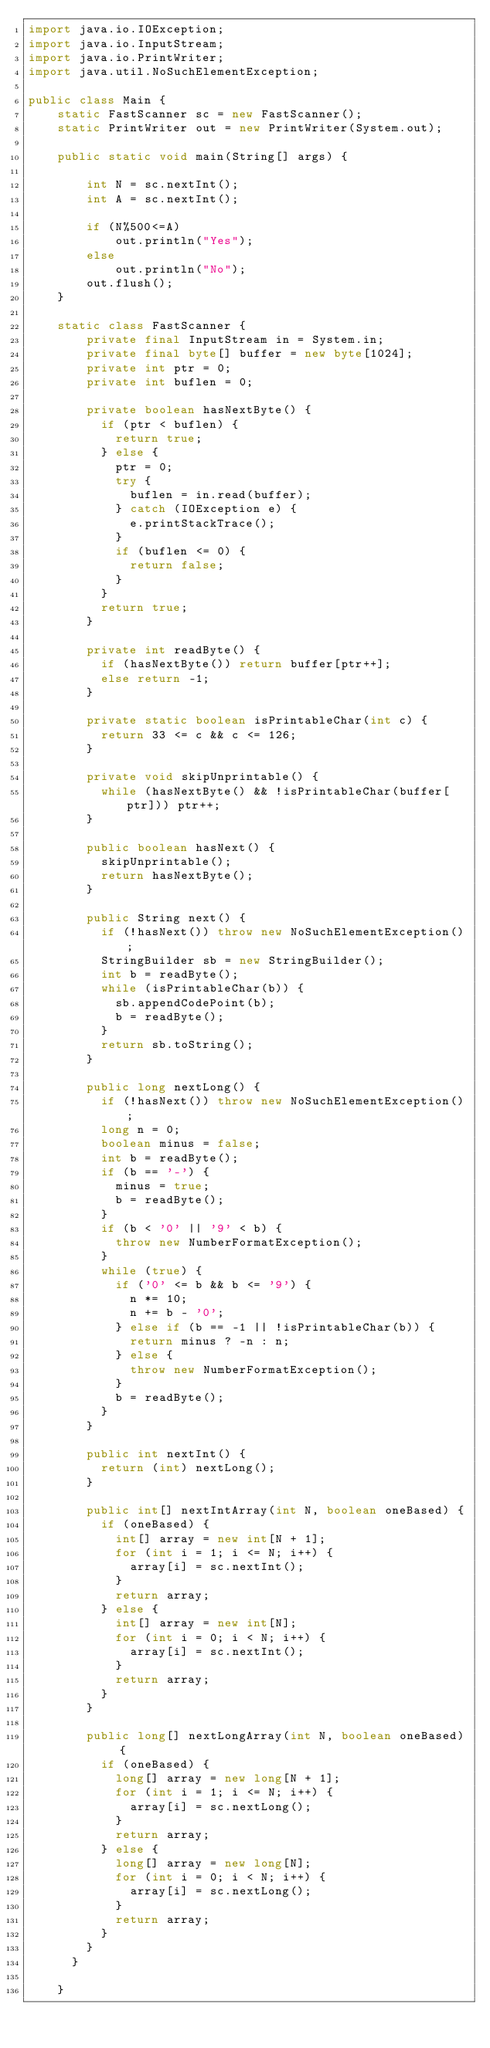<code> <loc_0><loc_0><loc_500><loc_500><_Java_>import java.io.IOException;
import java.io.InputStream;
import java.io.PrintWriter;
import java.util.NoSuchElementException;

public class Main {
	static FastScanner sc = new FastScanner();
	static PrintWriter out = new PrintWriter(System.out);
	
	public static void main(String[] args) {
		
		int N = sc.nextInt();
		int A = sc.nextInt();
		
		if (N%500<=A)
			out.println("Yes");
		else
			out.println("No");
		out.flush();
	}
	
	static class FastScanner {
	    private final InputStream in = System.in;
	    private final byte[] buffer = new byte[1024];
	    private int ptr = 0;
	    private int buflen = 0;

	    private boolean hasNextByte() {
	      if (ptr < buflen) {
	        return true;
	      } else {
	        ptr = 0;
	        try {
	          buflen = in.read(buffer);
	        } catch (IOException e) {
	          e.printStackTrace();
	        }
	        if (buflen <= 0) {
	          return false;
	        }
	      }
	      return true;
	    }

	    private int readByte() {
	      if (hasNextByte()) return buffer[ptr++];
	      else return -1;
	    }

	    private static boolean isPrintableChar(int c) {
	      return 33 <= c && c <= 126;
	    }

	    private void skipUnprintable() {
	      while (hasNextByte() && !isPrintableChar(buffer[ptr])) ptr++;
	    }

	    public boolean hasNext() {
	      skipUnprintable();
	      return hasNextByte();
	    }

	    public String next() {
	      if (!hasNext()) throw new NoSuchElementException();
	      StringBuilder sb = new StringBuilder();
	      int b = readByte();
	      while (isPrintableChar(b)) {
	        sb.appendCodePoint(b);
	        b = readByte();
	      }
	      return sb.toString();
	    }

	    public long nextLong() {
	      if (!hasNext()) throw new NoSuchElementException();
	      long n = 0;
	      boolean minus = false;
	      int b = readByte();
	      if (b == '-') {
	        minus = true;
	        b = readByte();
	      }
	      if (b < '0' || '9' < b) {
	        throw new NumberFormatException();
	      }
	      while (true) {
	        if ('0' <= b && b <= '9') {
	          n *= 10;
	          n += b - '0';
	        } else if (b == -1 || !isPrintableChar(b)) {
	          return minus ? -n : n;
	        } else {
	          throw new NumberFormatException();
	        }
	        b = readByte();
	      }
	    }

	    public int nextInt() {
	      return (int) nextLong();
	    }

	    public int[] nextIntArray(int N, boolean oneBased) {
	      if (oneBased) {
	        int[] array = new int[N + 1];
	        for (int i = 1; i <= N; i++) {
	          array[i] = sc.nextInt();
	        }
	        return array;
	      } else {
	        int[] array = new int[N];
	        for (int i = 0; i < N; i++) {
	          array[i] = sc.nextInt();
	        }
	        return array;
	      }
	    }

	    public long[] nextLongArray(int N, boolean oneBased) {
	      if (oneBased) {
	        long[] array = new long[N + 1];
	        for (int i = 1; i <= N; i++) {
	          array[i] = sc.nextLong();
	        }
	        return array;
	      } else {
	        long[] array = new long[N];
	        for (int i = 0; i < N; i++) {
	          array[i] = sc.nextLong();
	        }
	        return array;
	      }
	    }
	  }

	}	 		



</code> 